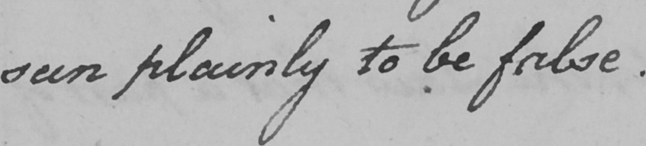What text is written in this handwritten line? seen plainly to be false . 